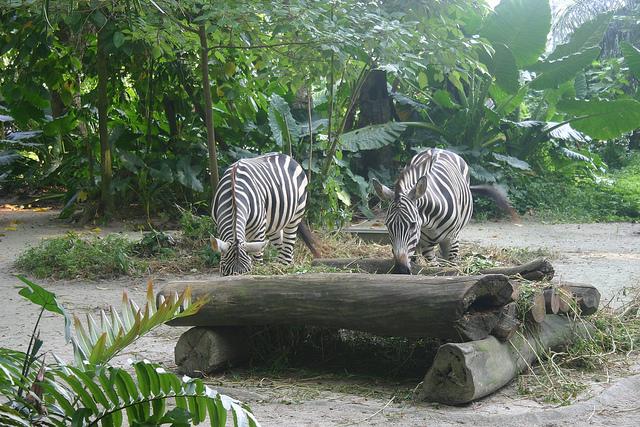What color is the foliage?
Concise answer only. Green. How many animals?
Be succinct. 2. What kind of animal?
Answer briefly. Zebra. 